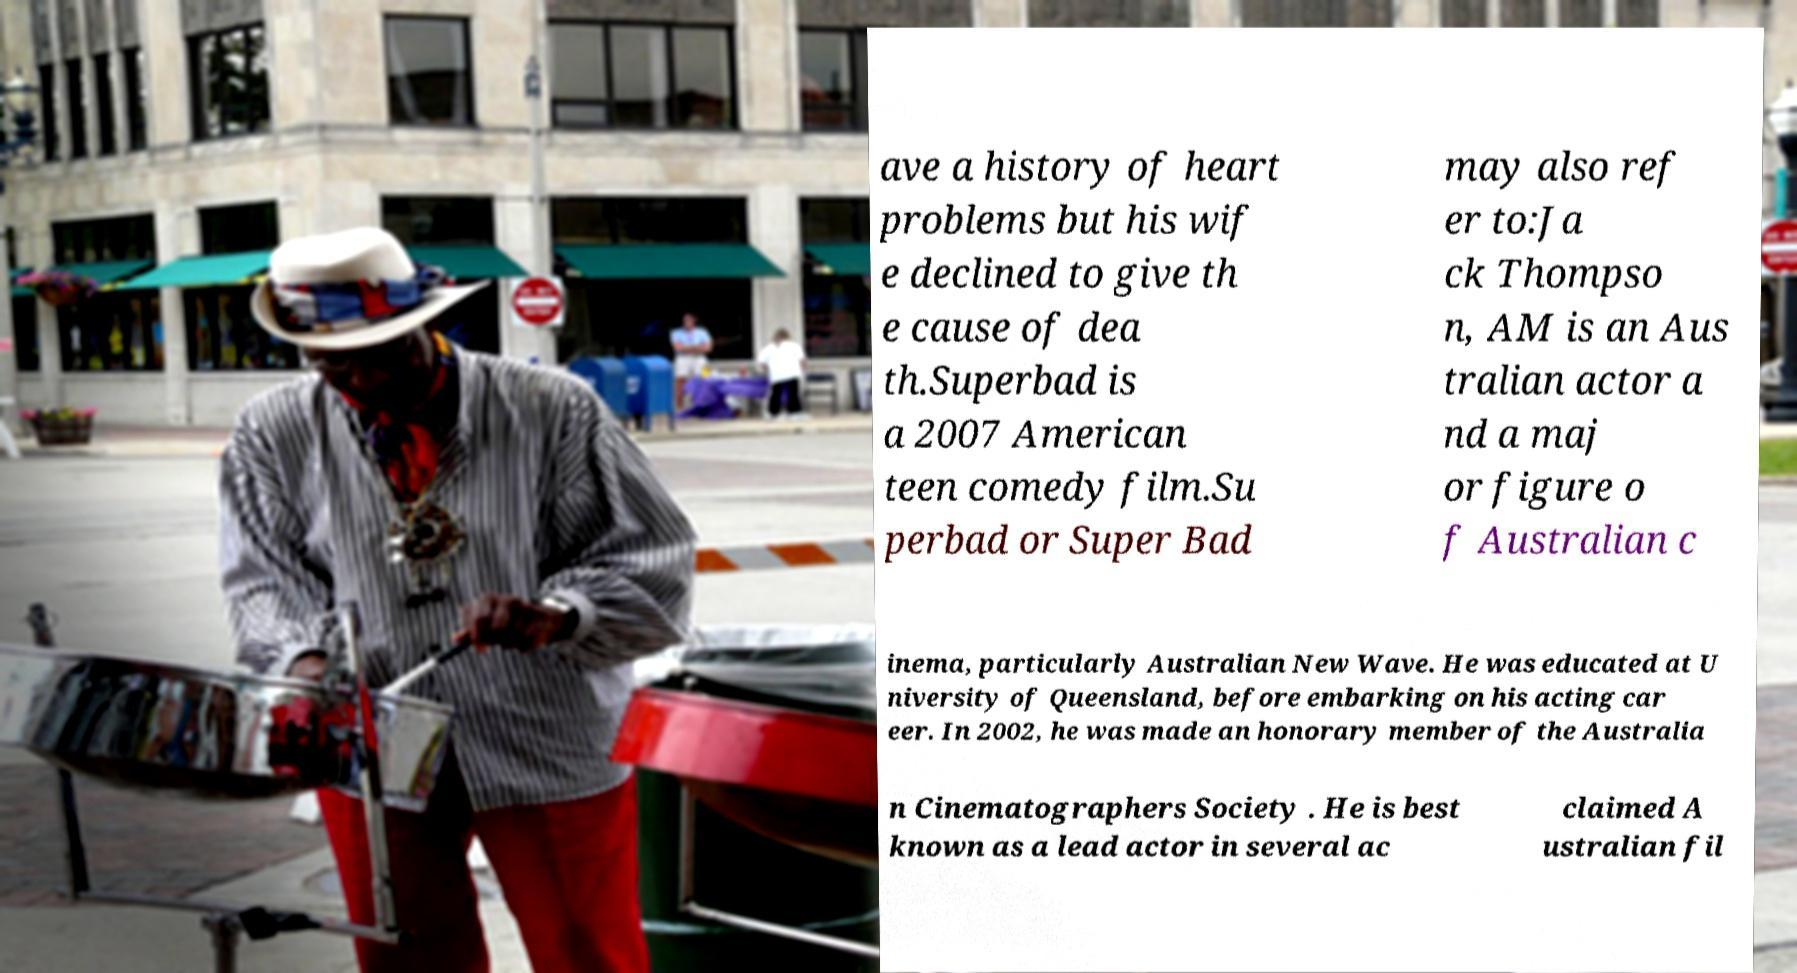Can you accurately transcribe the text from the provided image for me? ave a history of heart problems but his wif e declined to give th e cause of dea th.Superbad is a 2007 American teen comedy film.Su perbad or Super Bad may also ref er to:Ja ck Thompso n, AM is an Aus tralian actor a nd a maj or figure o f Australian c inema, particularly Australian New Wave. He was educated at U niversity of Queensland, before embarking on his acting car eer. In 2002, he was made an honorary member of the Australia n Cinematographers Society . He is best known as a lead actor in several ac claimed A ustralian fil 